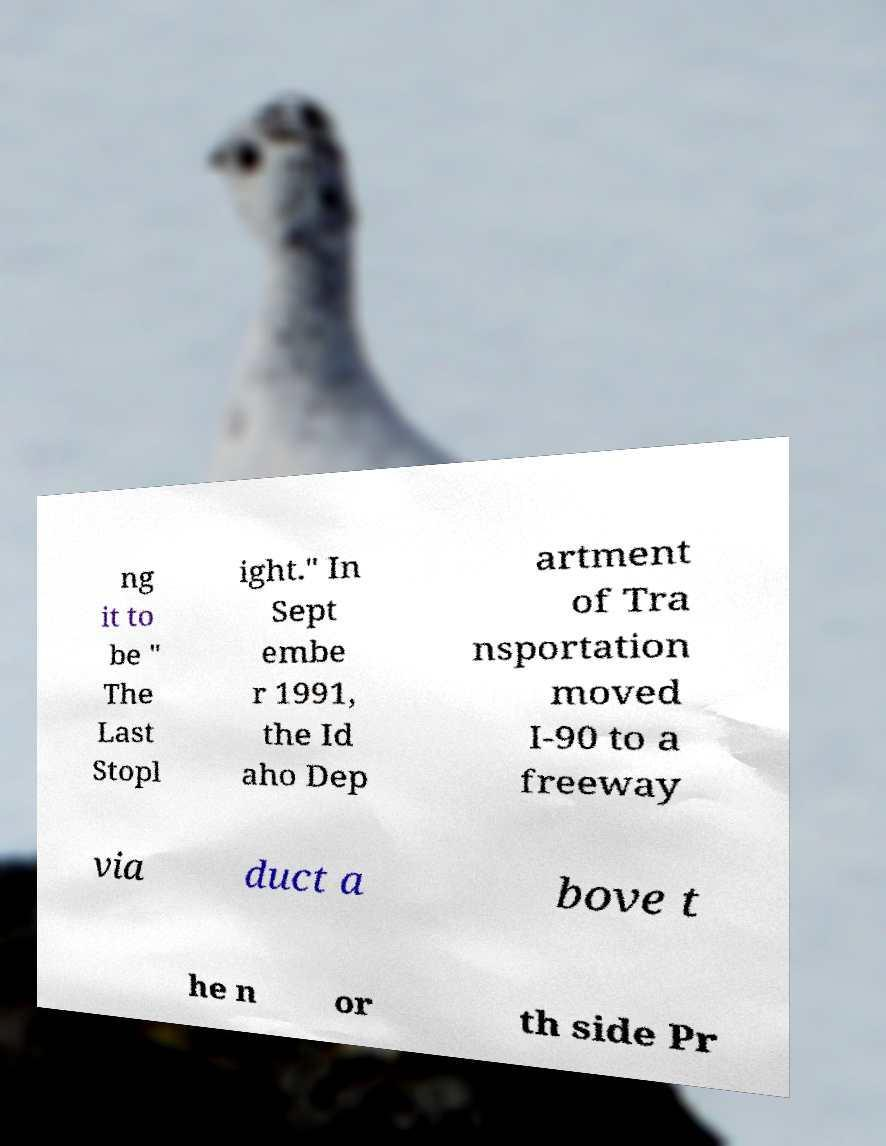Could you extract and type out the text from this image? ng it to be " The Last Stopl ight." In Sept embe r 1991, the Id aho Dep artment of Tra nsportation moved I-90 to a freeway via duct a bove t he n or th side Pr 